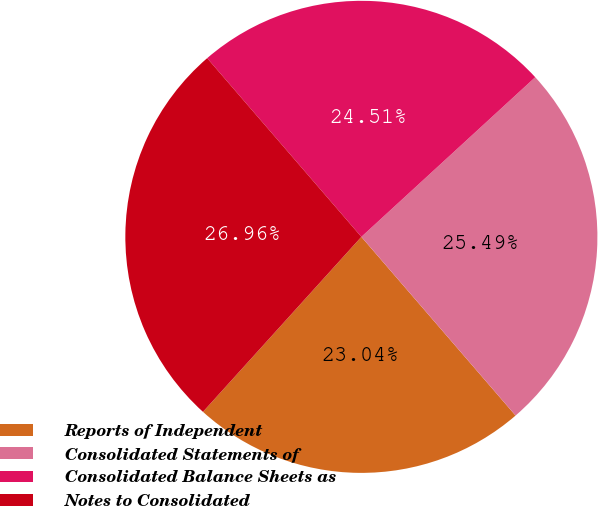<chart> <loc_0><loc_0><loc_500><loc_500><pie_chart><fcel>Reports of Independent<fcel>Consolidated Statements of<fcel>Consolidated Balance Sheets as<fcel>Notes to Consolidated<nl><fcel>23.04%<fcel>25.49%<fcel>24.51%<fcel>26.96%<nl></chart> 